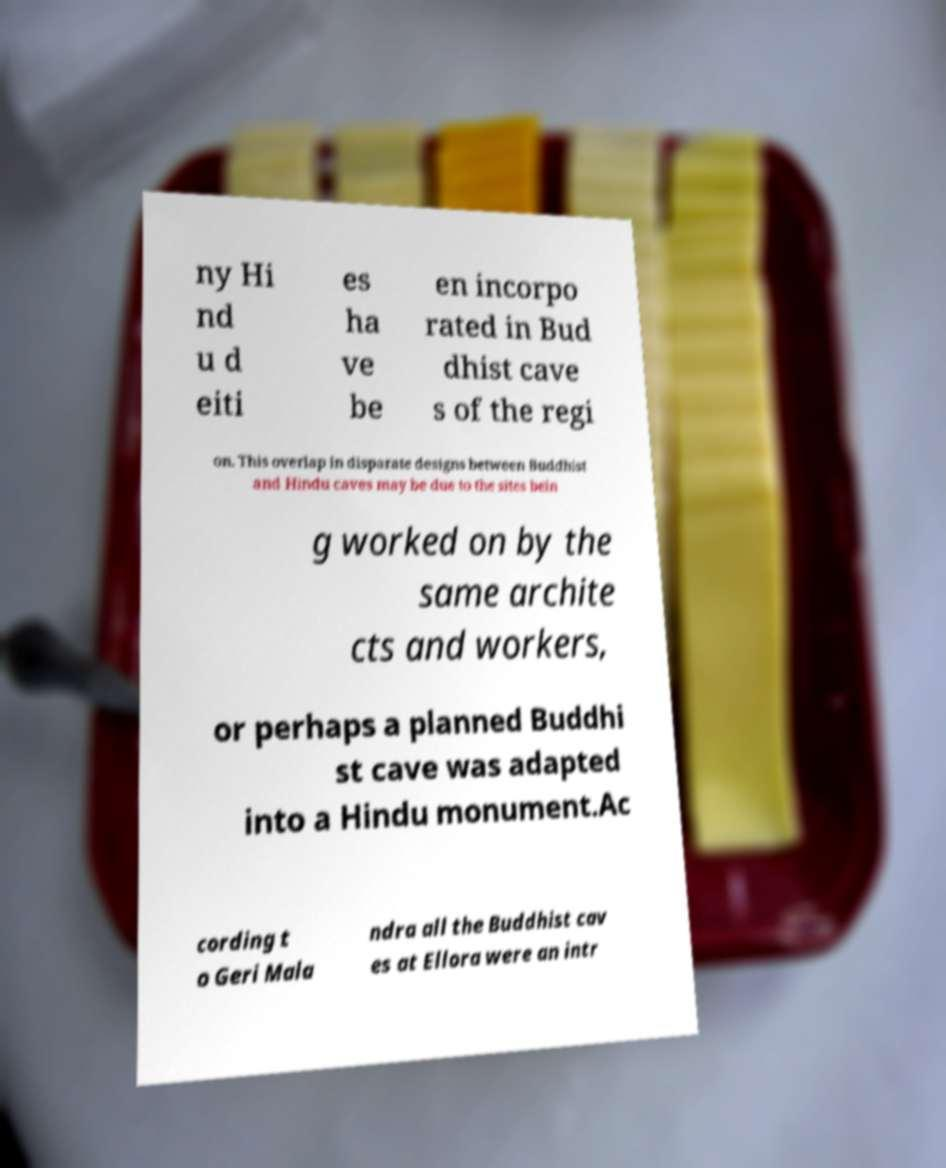There's text embedded in this image that I need extracted. Can you transcribe it verbatim? ny Hi nd u d eiti es ha ve be en incorpo rated in Bud dhist cave s of the regi on. This overlap in disparate designs between Buddhist and Hindu caves may be due to the sites bein g worked on by the same archite cts and workers, or perhaps a planned Buddhi st cave was adapted into a Hindu monument.Ac cording t o Geri Mala ndra all the Buddhist cav es at Ellora were an intr 